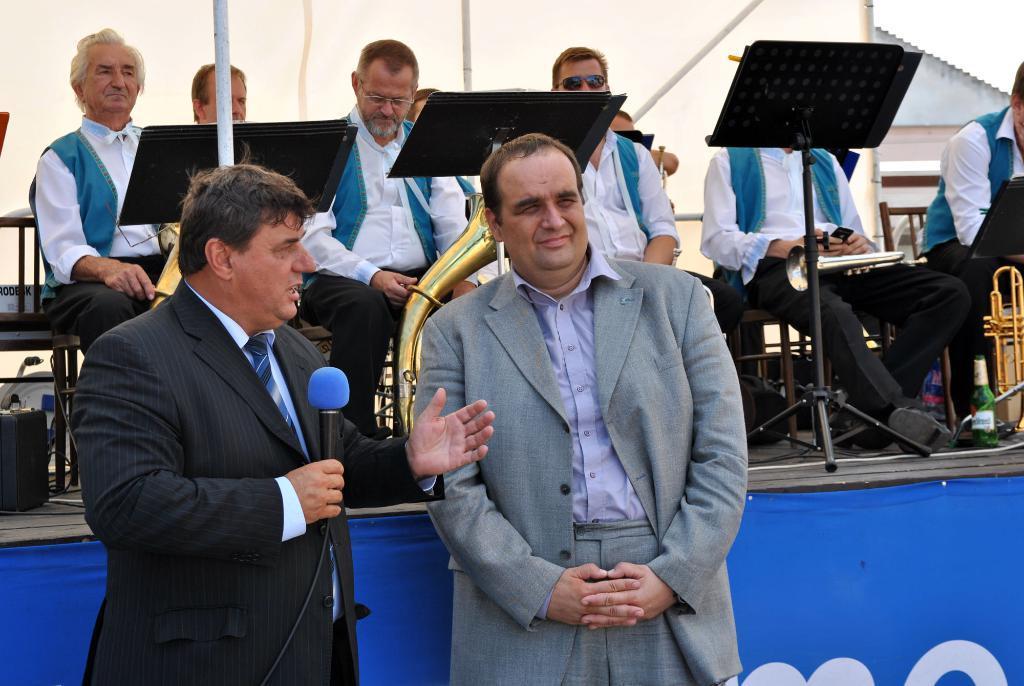Can you describe this image briefly? In this picture there is a person with black suit is standing and holding the microphone and he is talking. There is a person with grey suit is standing. At the back there are group of people sitting on the chairs and holding the musical instruments. There are objects and devices on the stage. At the back there is a building. At the bottom there is a hoarding and there is a text on the hoarding. 